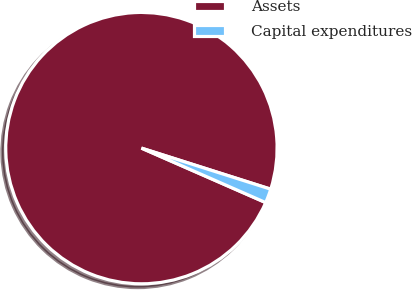<chart> <loc_0><loc_0><loc_500><loc_500><pie_chart><fcel>Assets<fcel>Capital expenditures<nl><fcel>98.32%<fcel>1.68%<nl></chart> 